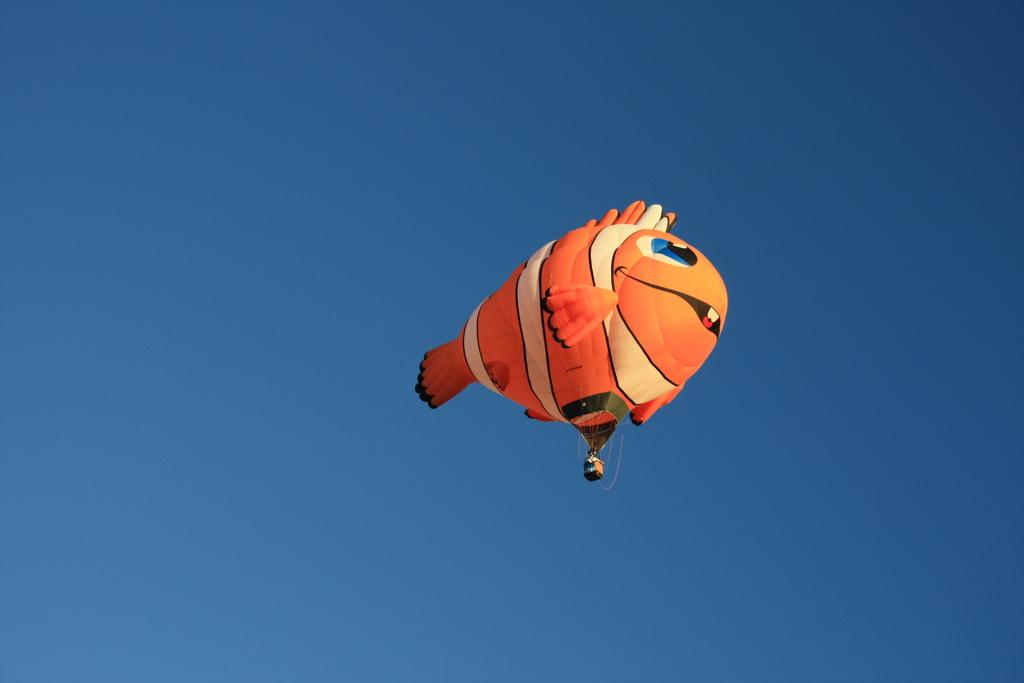What is the main subject of the image? The main subject of the image is a hot air balloon. What is unique about the design of the hot air balloon? The hot air balloon is in the shape of a fish. What colors are used to paint the hot air balloon? The hot air balloon has orange and white colors. Where is the hot air balloon located in the image? The hot air balloon is in the air. What can be seen in the background of the image? There is sky visible in the background of the image. What type of tent can be seen near the coast in the image? There is no tent or coast present in the image; it features a hot air balloon in the shape of a fish. What unit of measurement is used to determine the size of the hot air balloon in the image? The size of the hot air balloon cannot be determined by a unit of measurement from the image alone, as it is a two-dimensional representation. 